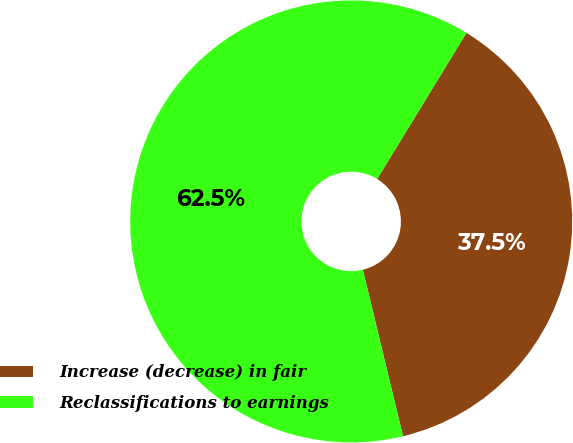Convert chart. <chart><loc_0><loc_0><loc_500><loc_500><pie_chart><fcel>Increase (decrease) in fair<fcel>Reclassifications to earnings<nl><fcel>37.5%<fcel>62.5%<nl></chart> 